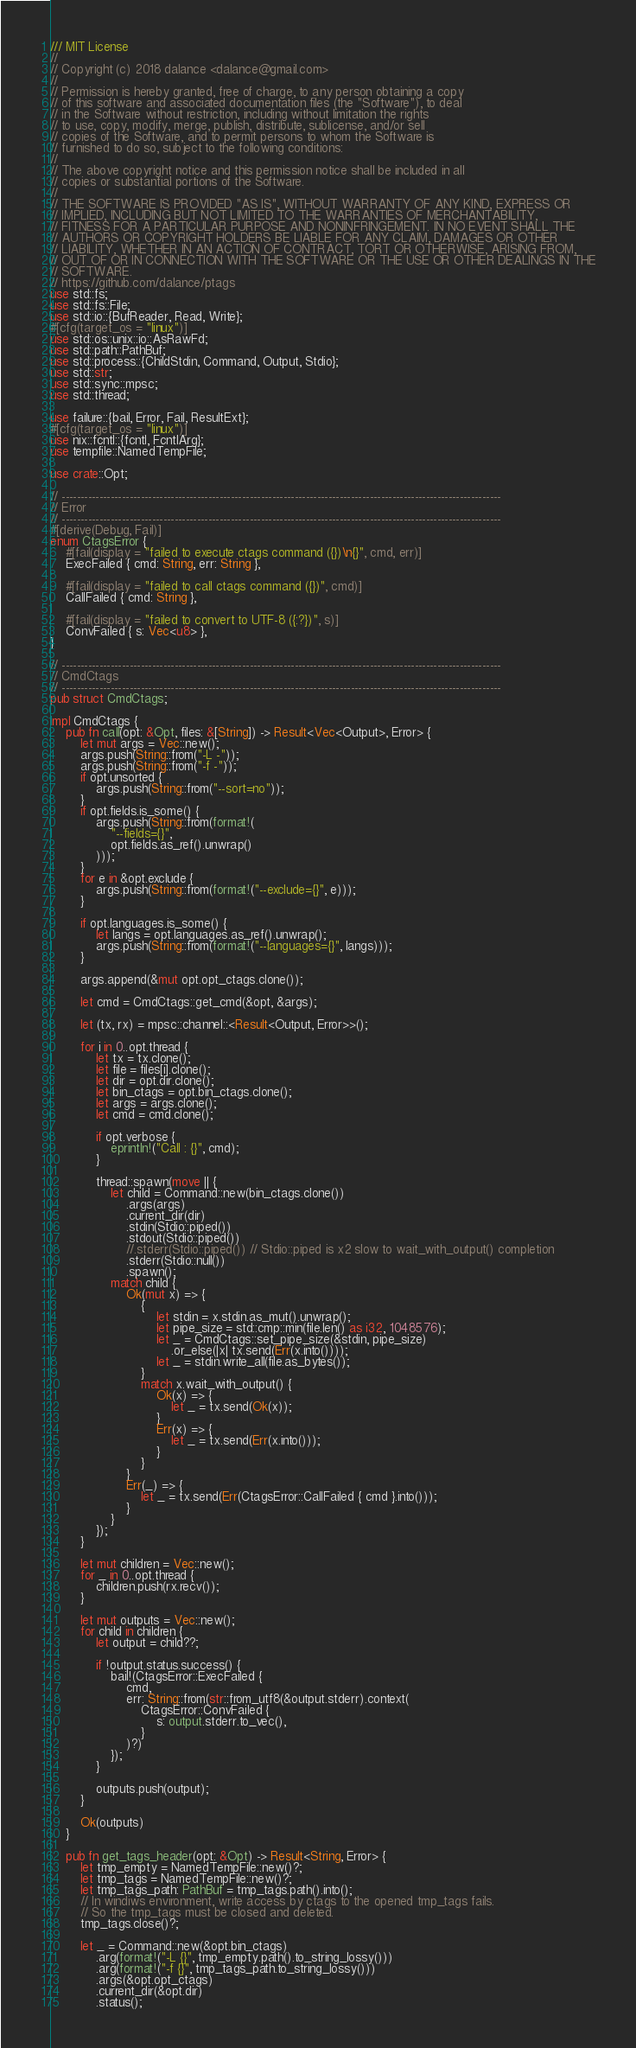Convert code to text. <code><loc_0><loc_0><loc_500><loc_500><_Rust_>/// MIT License
//
// Copyright (c) 2018 dalance <dalance@gmail.com>
//
// Permission is hereby granted, free of charge, to any person obtaining a copy
// of this software and associated documentation files (the "Software"), to deal
// in the Software without restriction, including without limitation the rights
// to use, copy, modify, merge, publish, distribute, sublicense, and/or sell
// copies of the Software, and to permit persons to whom the Software is
// furnished to do so, subject to the following conditions:
//
// The above copyright notice and this permission notice shall be included in all
// copies or substantial portions of the Software.
//
// THE SOFTWARE IS PROVIDED "AS IS", WITHOUT WARRANTY OF ANY KIND, EXPRESS OR
// IMPLIED, INCLUDING BUT NOT LIMITED TO THE WARRANTIES OF MERCHANTABILITY,
// FITNESS FOR A PARTICULAR PURPOSE AND NONINFRINGEMENT. IN NO EVENT SHALL THE
// AUTHORS OR COPYRIGHT HOLDERS BE LIABLE FOR ANY CLAIM, DAMAGES OR OTHER
// LIABILITY, WHETHER IN AN ACTION OF CONTRACT, TORT OR OTHERWISE, ARISING FROM,
// OUT OF OR IN CONNECTION WITH THE SOFTWARE OR THE USE OR OTHER DEALINGS IN THE
// SOFTWARE.
// https://github.com/dalance/ptags
use std::fs;
use std::fs::File;
use std::io::{BufReader, Read, Write};
#[cfg(target_os = "linux")]
use std::os::unix::io::AsRawFd;
use std::path::PathBuf;
use std::process::{ChildStdin, Command, Output, Stdio};
use std::str;
use std::sync::mpsc;
use std::thread;

use failure::{bail, Error, Fail, ResultExt};
#[cfg(target_os = "linux")]
use nix::fcntl::{fcntl, FcntlArg};
use tempfile::NamedTempFile;

use crate::Opt;

// ---------------------------------------------------------------------------------------------------------------------
// Error
// ---------------------------------------------------------------------------------------------------------------------
#[derive(Debug, Fail)]
enum CtagsError {
    #[fail(display = "failed to execute ctags command ({})\n{}", cmd, err)]
    ExecFailed { cmd: String, err: String },

    #[fail(display = "failed to call ctags command ({})", cmd)]
    CallFailed { cmd: String },

    #[fail(display = "failed to convert to UTF-8 ({:?})", s)]
    ConvFailed { s: Vec<u8> },
}

// ---------------------------------------------------------------------------------------------------------------------
// CmdCtags
// ---------------------------------------------------------------------------------------------------------------------
pub struct CmdCtags;

impl CmdCtags {
    pub fn call(opt: &Opt, files: &[String]) -> Result<Vec<Output>, Error> {
        let mut args = Vec::new();
        args.push(String::from("-L -"));
        args.push(String::from("-f -"));
        if opt.unsorted {
            args.push(String::from("--sort=no"));
        }
        if opt.fields.is_some() {
            args.push(String::from(format!(
                "--fields={}",
                opt.fields.as_ref().unwrap()
            )));
        }
        for e in &opt.exclude {
            args.push(String::from(format!("--exclude={}", e)));
        }

        if opt.languages.is_some() {
            let langs = opt.languages.as_ref().unwrap();
            args.push(String::from(format!("--languages={}", langs)));
        }

        args.append(&mut opt.opt_ctags.clone());

        let cmd = CmdCtags::get_cmd(&opt, &args);

        let (tx, rx) = mpsc::channel::<Result<Output, Error>>();

        for i in 0..opt.thread {
            let tx = tx.clone();
            let file = files[i].clone();
            let dir = opt.dir.clone();
            let bin_ctags = opt.bin_ctags.clone();
            let args = args.clone();
            let cmd = cmd.clone();

            if opt.verbose {
                eprintln!("Call : {}", cmd);
            }

            thread::spawn(move || {
                let child = Command::new(bin_ctags.clone())
                    .args(args)
                    .current_dir(dir)
                    .stdin(Stdio::piped())
                    .stdout(Stdio::piped())
                    //.stderr(Stdio::piped()) // Stdio::piped is x2 slow to wait_with_output() completion
                    .stderr(Stdio::null())
                    .spawn();
                match child {
                    Ok(mut x) => {
                        {
                            let stdin = x.stdin.as_mut().unwrap();
                            let pipe_size = std::cmp::min(file.len() as i32, 1048576);
                            let _ = CmdCtags::set_pipe_size(&stdin, pipe_size)
                                .or_else(|x| tx.send(Err(x.into())));
                            let _ = stdin.write_all(file.as_bytes());
                        }
                        match x.wait_with_output() {
                            Ok(x) => {
                                let _ = tx.send(Ok(x));
                            }
                            Err(x) => {
                                let _ = tx.send(Err(x.into()));
                            }
                        }
                    }
                    Err(_) => {
                        let _ = tx.send(Err(CtagsError::CallFailed { cmd }.into()));
                    }
                }
            });
        }

        let mut children = Vec::new();
        for _ in 0..opt.thread {
            children.push(rx.recv());
        }

        let mut outputs = Vec::new();
        for child in children {
            let output = child??;

            if !output.status.success() {
                bail!(CtagsError::ExecFailed {
                    cmd,
                    err: String::from(str::from_utf8(&output.stderr).context(
                        CtagsError::ConvFailed {
                            s: output.stderr.to_vec(),
                        }
                    )?)
                });
            }

            outputs.push(output);
        }

        Ok(outputs)
    }

    pub fn get_tags_header(opt: &Opt) -> Result<String, Error> {
        let tmp_empty = NamedTempFile::new()?;
        let tmp_tags = NamedTempFile::new()?;
        let tmp_tags_path: PathBuf = tmp_tags.path().into();
        // In windiws environment, write access by ctags to the opened tmp_tags fails.
        // So the tmp_tags must be closed and deleted.
        tmp_tags.close()?;

        let _ = Command::new(&opt.bin_ctags)
            .arg(format!("-L {}", tmp_empty.path().to_string_lossy()))
            .arg(format!("-f {}", tmp_tags_path.to_string_lossy()))
            .args(&opt.opt_ctags)
            .current_dir(&opt.dir)
            .status();</code> 